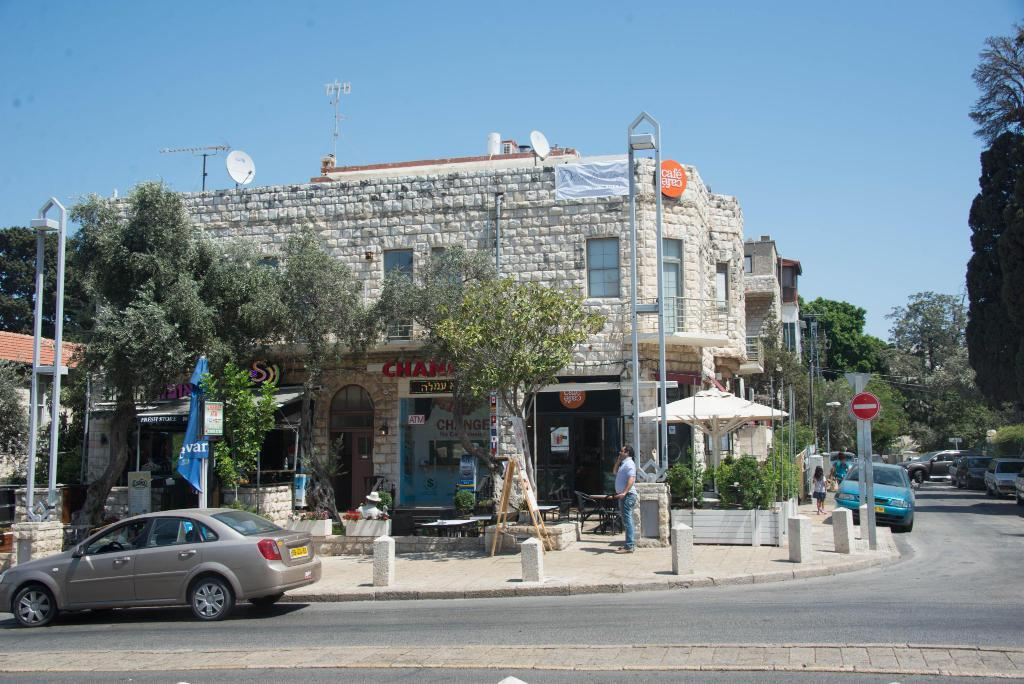What is happening on the road in the image? There are vehicles on a road in the image. What are people doing in the image? People are walking on a footpath in the image. What can be seen in the background of the image? There are trees, poles, buildings, and the sky visible in the background of the image. Can you tell me how many vessels are docked at the airport in the image? There is no airport or vessel present in the image; it features a road with vehicles and people walking on a footpath. What type of loss is depicted in the image? There is no loss depicted in the image; it shows a scene with vehicles, people, and background elements such as trees, poles, buildings, and the sky. 